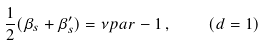<formula> <loc_0><loc_0><loc_500><loc_500>\frac { 1 } { 2 } ( \beta _ { s } + \beta _ { s } ^ { \prime } ) = \nu p a r - 1 \, , \quad ( d = 1 )</formula> 